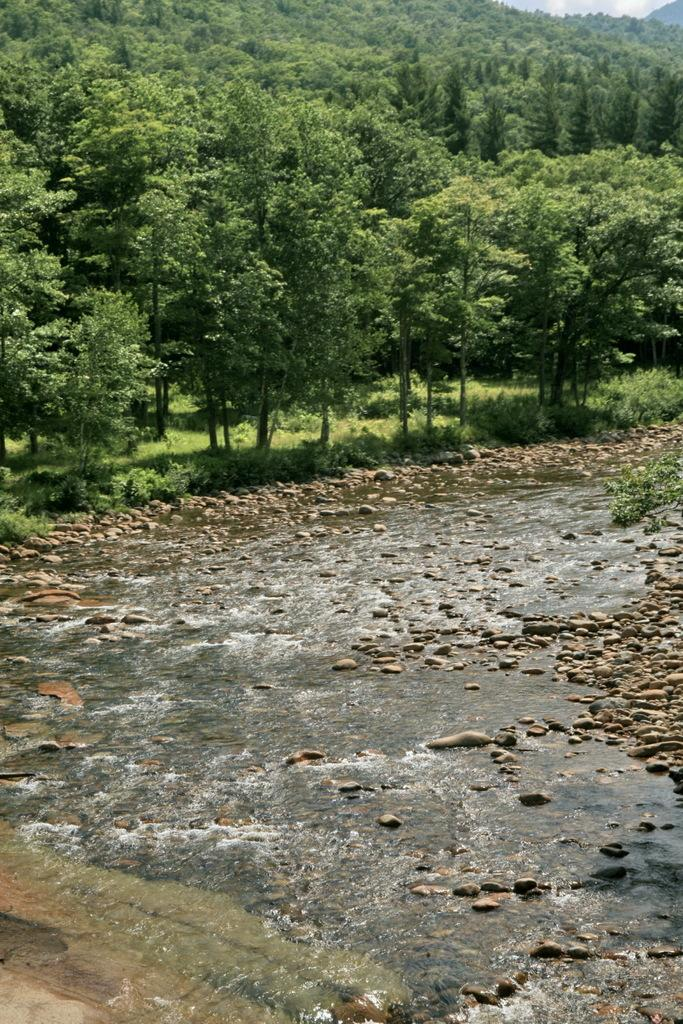What is visible at the top of the image? The sky, hills, trees, and grass are visible at the top of the image. What is present at the bottom of the image? Flowing water, rocks, and stones are visible at the bottom of the image. What design is used for the guide in the image? There is no guide present in the image, and therefore no design can be observed. What type of war is depicted in the image? There is no war depicted in the image; it features natural elements such as hills, trees, grass, flowing water, rocks, and stones. 